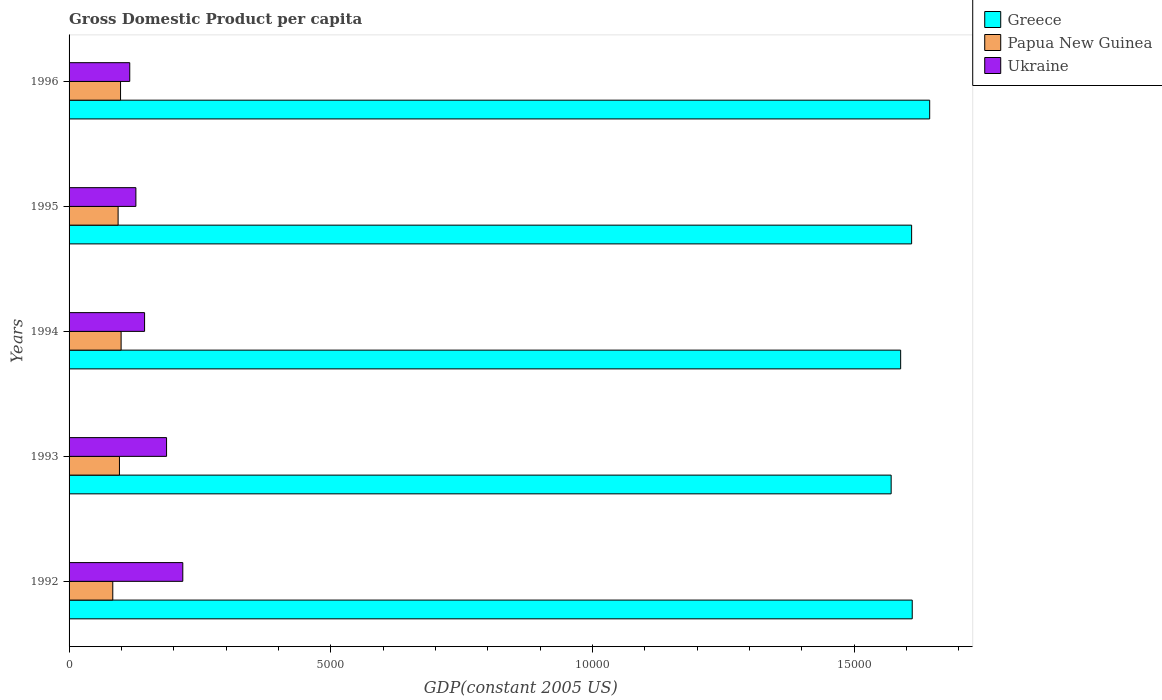How many different coloured bars are there?
Provide a short and direct response. 3. How many groups of bars are there?
Provide a short and direct response. 5. Are the number of bars per tick equal to the number of legend labels?
Your answer should be compact. Yes. What is the label of the 3rd group of bars from the top?
Offer a very short reply. 1994. In how many cases, is the number of bars for a given year not equal to the number of legend labels?
Make the answer very short. 0. What is the GDP per capita in Ukraine in 1996?
Your answer should be very brief. 1159.47. Across all years, what is the maximum GDP per capita in Papua New Guinea?
Make the answer very short. 994.42. Across all years, what is the minimum GDP per capita in Greece?
Provide a short and direct response. 1.57e+04. In which year was the GDP per capita in Ukraine maximum?
Keep it short and to the point. 1992. What is the total GDP per capita in Papua New Guinea in the graph?
Your response must be concise. 4713.17. What is the difference between the GDP per capita in Greece in 1993 and that in 1996?
Provide a short and direct response. -736.03. What is the difference between the GDP per capita in Papua New Guinea in 1996 and the GDP per capita in Greece in 1995?
Offer a very short reply. -1.51e+04. What is the average GDP per capita in Ukraine per year?
Offer a very short reply. 1583.11. In the year 1993, what is the difference between the GDP per capita in Ukraine and GDP per capita in Papua New Guinea?
Ensure brevity in your answer.  900.2. In how many years, is the GDP per capita in Papua New Guinea greater than 3000 US$?
Offer a very short reply. 0. What is the ratio of the GDP per capita in Greece in 1993 to that in 1996?
Your response must be concise. 0.96. Is the GDP per capita in Papua New Guinea in 1994 less than that in 1995?
Your response must be concise. No. Is the difference between the GDP per capita in Ukraine in 1994 and 1996 greater than the difference between the GDP per capita in Papua New Guinea in 1994 and 1996?
Your answer should be very brief. Yes. What is the difference between the highest and the second highest GDP per capita in Greece?
Your answer should be compact. 333.31. What is the difference between the highest and the lowest GDP per capita in Ukraine?
Offer a terse response. 1013.76. Is the sum of the GDP per capita in Greece in 1992 and 1993 greater than the maximum GDP per capita in Papua New Guinea across all years?
Offer a terse response. Yes. What does the 2nd bar from the top in 1996 represents?
Make the answer very short. Papua New Guinea. Are all the bars in the graph horizontal?
Keep it short and to the point. Yes. How many years are there in the graph?
Make the answer very short. 5. Are the values on the major ticks of X-axis written in scientific E-notation?
Make the answer very short. No. Does the graph contain grids?
Your answer should be very brief. No. Where does the legend appear in the graph?
Your response must be concise. Top right. How are the legend labels stacked?
Provide a succinct answer. Vertical. What is the title of the graph?
Ensure brevity in your answer.  Gross Domestic Product per capita. Does "Indonesia" appear as one of the legend labels in the graph?
Your answer should be very brief. No. What is the label or title of the X-axis?
Your response must be concise. GDP(constant 2005 US). What is the label or title of the Y-axis?
Provide a succinct answer. Years. What is the GDP(constant 2005 US) in Greece in 1992?
Give a very brief answer. 1.61e+04. What is the GDP(constant 2005 US) in Papua New Guinea in 1992?
Provide a short and direct response. 835.3. What is the GDP(constant 2005 US) of Ukraine in 1992?
Keep it short and to the point. 2173.23. What is the GDP(constant 2005 US) in Greece in 1993?
Give a very brief answer. 1.57e+04. What is the GDP(constant 2005 US) of Papua New Guinea in 1993?
Give a very brief answer. 962.82. What is the GDP(constant 2005 US) in Ukraine in 1993?
Offer a terse response. 1863.03. What is the GDP(constant 2005 US) in Greece in 1994?
Offer a very short reply. 1.59e+04. What is the GDP(constant 2005 US) in Papua New Guinea in 1994?
Provide a short and direct response. 994.42. What is the GDP(constant 2005 US) of Ukraine in 1994?
Give a very brief answer. 1442.9. What is the GDP(constant 2005 US) in Greece in 1995?
Provide a short and direct response. 1.61e+04. What is the GDP(constant 2005 US) in Papua New Guinea in 1995?
Your response must be concise. 937.05. What is the GDP(constant 2005 US) in Ukraine in 1995?
Offer a very short reply. 1276.92. What is the GDP(constant 2005 US) in Greece in 1996?
Give a very brief answer. 1.64e+04. What is the GDP(constant 2005 US) of Papua New Guinea in 1996?
Provide a succinct answer. 983.58. What is the GDP(constant 2005 US) of Ukraine in 1996?
Offer a very short reply. 1159.47. Across all years, what is the maximum GDP(constant 2005 US) of Greece?
Your answer should be compact. 1.64e+04. Across all years, what is the maximum GDP(constant 2005 US) in Papua New Guinea?
Give a very brief answer. 994.42. Across all years, what is the maximum GDP(constant 2005 US) in Ukraine?
Make the answer very short. 2173.23. Across all years, what is the minimum GDP(constant 2005 US) of Greece?
Your answer should be compact. 1.57e+04. Across all years, what is the minimum GDP(constant 2005 US) of Papua New Guinea?
Make the answer very short. 835.3. Across all years, what is the minimum GDP(constant 2005 US) in Ukraine?
Provide a short and direct response. 1159.47. What is the total GDP(constant 2005 US) in Greece in the graph?
Make the answer very short. 8.03e+04. What is the total GDP(constant 2005 US) in Papua New Guinea in the graph?
Ensure brevity in your answer.  4713.17. What is the total GDP(constant 2005 US) of Ukraine in the graph?
Ensure brevity in your answer.  7915.54. What is the difference between the GDP(constant 2005 US) in Greece in 1992 and that in 1993?
Your answer should be compact. 402.72. What is the difference between the GDP(constant 2005 US) of Papua New Guinea in 1992 and that in 1993?
Offer a terse response. -127.52. What is the difference between the GDP(constant 2005 US) of Ukraine in 1992 and that in 1993?
Provide a succinct answer. 310.2. What is the difference between the GDP(constant 2005 US) of Greece in 1992 and that in 1994?
Offer a terse response. 221.4. What is the difference between the GDP(constant 2005 US) in Papua New Guinea in 1992 and that in 1994?
Your response must be concise. -159.11. What is the difference between the GDP(constant 2005 US) of Ukraine in 1992 and that in 1994?
Offer a terse response. 730.33. What is the difference between the GDP(constant 2005 US) in Greece in 1992 and that in 1995?
Offer a terse response. 11.85. What is the difference between the GDP(constant 2005 US) of Papua New Guinea in 1992 and that in 1995?
Give a very brief answer. -101.75. What is the difference between the GDP(constant 2005 US) of Ukraine in 1992 and that in 1995?
Your answer should be compact. 896.31. What is the difference between the GDP(constant 2005 US) of Greece in 1992 and that in 1996?
Make the answer very short. -333.31. What is the difference between the GDP(constant 2005 US) in Papua New Guinea in 1992 and that in 1996?
Provide a succinct answer. -148.28. What is the difference between the GDP(constant 2005 US) of Ukraine in 1992 and that in 1996?
Your response must be concise. 1013.76. What is the difference between the GDP(constant 2005 US) in Greece in 1993 and that in 1994?
Your response must be concise. -181.32. What is the difference between the GDP(constant 2005 US) in Papua New Guinea in 1993 and that in 1994?
Make the answer very short. -31.59. What is the difference between the GDP(constant 2005 US) in Ukraine in 1993 and that in 1994?
Provide a short and direct response. 420.13. What is the difference between the GDP(constant 2005 US) of Greece in 1993 and that in 1995?
Offer a terse response. -390.87. What is the difference between the GDP(constant 2005 US) of Papua New Guinea in 1993 and that in 1995?
Keep it short and to the point. 25.77. What is the difference between the GDP(constant 2005 US) of Ukraine in 1993 and that in 1995?
Your answer should be very brief. 586.11. What is the difference between the GDP(constant 2005 US) of Greece in 1993 and that in 1996?
Provide a succinct answer. -736.03. What is the difference between the GDP(constant 2005 US) of Papua New Guinea in 1993 and that in 1996?
Offer a terse response. -20.75. What is the difference between the GDP(constant 2005 US) of Ukraine in 1993 and that in 1996?
Ensure brevity in your answer.  703.56. What is the difference between the GDP(constant 2005 US) of Greece in 1994 and that in 1995?
Provide a short and direct response. -209.55. What is the difference between the GDP(constant 2005 US) of Papua New Guinea in 1994 and that in 1995?
Give a very brief answer. 57.36. What is the difference between the GDP(constant 2005 US) in Ukraine in 1994 and that in 1995?
Offer a terse response. 165.98. What is the difference between the GDP(constant 2005 US) in Greece in 1994 and that in 1996?
Ensure brevity in your answer.  -554.71. What is the difference between the GDP(constant 2005 US) of Papua New Guinea in 1994 and that in 1996?
Ensure brevity in your answer.  10.84. What is the difference between the GDP(constant 2005 US) of Ukraine in 1994 and that in 1996?
Your response must be concise. 283.43. What is the difference between the GDP(constant 2005 US) in Greece in 1995 and that in 1996?
Your response must be concise. -345.16. What is the difference between the GDP(constant 2005 US) in Papua New Guinea in 1995 and that in 1996?
Your answer should be compact. -46.53. What is the difference between the GDP(constant 2005 US) in Ukraine in 1995 and that in 1996?
Offer a terse response. 117.45. What is the difference between the GDP(constant 2005 US) of Greece in 1992 and the GDP(constant 2005 US) of Papua New Guinea in 1993?
Make the answer very short. 1.51e+04. What is the difference between the GDP(constant 2005 US) in Greece in 1992 and the GDP(constant 2005 US) in Ukraine in 1993?
Your answer should be compact. 1.42e+04. What is the difference between the GDP(constant 2005 US) in Papua New Guinea in 1992 and the GDP(constant 2005 US) in Ukraine in 1993?
Make the answer very short. -1027.72. What is the difference between the GDP(constant 2005 US) in Greece in 1992 and the GDP(constant 2005 US) in Papua New Guinea in 1994?
Give a very brief answer. 1.51e+04. What is the difference between the GDP(constant 2005 US) in Greece in 1992 and the GDP(constant 2005 US) in Ukraine in 1994?
Your answer should be compact. 1.47e+04. What is the difference between the GDP(constant 2005 US) in Papua New Guinea in 1992 and the GDP(constant 2005 US) in Ukraine in 1994?
Keep it short and to the point. -607.6. What is the difference between the GDP(constant 2005 US) in Greece in 1992 and the GDP(constant 2005 US) in Papua New Guinea in 1995?
Offer a very short reply. 1.52e+04. What is the difference between the GDP(constant 2005 US) in Greece in 1992 and the GDP(constant 2005 US) in Ukraine in 1995?
Make the answer very short. 1.48e+04. What is the difference between the GDP(constant 2005 US) in Papua New Guinea in 1992 and the GDP(constant 2005 US) in Ukraine in 1995?
Your answer should be very brief. -441.62. What is the difference between the GDP(constant 2005 US) of Greece in 1992 and the GDP(constant 2005 US) of Papua New Guinea in 1996?
Offer a terse response. 1.51e+04. What is the difference between the GDP(constant 2005 US) of Greece in 1992 and the GDP(constant 2005 US) of Ukraine in 1996?
Offer a very short reply. 1.50e+04. What is the difference between the GDP(constant 2005 US) in Papua New Guinea in 1992 and the GDP(constant 2005 US) in Ukraine in 1996?
Your response must be concise. -324.17. What is the difference between the GDP(constant 2005 US) in Greece in 1993 and the GDP(constant 2005 US) in Papua New Guinea in 1994?
Offer a terse response. 1.47e+04. What is the difference between the GDP(constant 2005 US) of Greece in 1993 and the GDP(constant 2005 US) of Ukraine in 1994?
Your answer should be very brief. 1.43e+04. What is the difference between the GDP(constant 2005 US) in Papua New Guinea in 1993 and the GDP(constant 2005 US) in Ukraine in 1994?
Provide a succinct answer. -480.07. What is the difference between the GDP(constant 2005 US) of Greece in 1993 and the GDP(constant 2005 US) of Papua New Guinea in 1995?
Ensure brevity in your answer.  1.48e+04. What is the difference between the GDP(constant 2005 US) of Greece in 1993 and the GDP(constant 2005 US) of Ukraine in 1995?
Your answer should be very brief. 1.44e+04. What is the difference between the GDP(constant 2005 US) in Papua New Guinea in 1993 and the GDP(constant 2005 US) in Ukraine in 1995?
Offer a very short reply. -314.09. What is the difference between the GDP(constant 2005 US) in Greece in 1993 and the GDP(constant 2005 US) in Papua New Guinea in 1996?
Your response must be concise. 1.47e+04. What is the difference between the GDP(constant 2005 US) of Greece in 1993 and the GDP(constant 2005 US) of Ukraine in 1996?
Make the answer very short. 1.46e+04. What is the difference between the GDP(constant 2005 US) in Papua New Guinea in 1993 and the GDP(constant 2005 US) in Ukraine in 1996?
Keep it short and to the point. -196.65. What is the difference between the GDP(constant 2005 US) of Greece in 1994 and the GDP(constant 2005 US) of Papua New Guinea in 1995?
Provide a succinct answer. 1.50e+04. What is the difference between the GDP(constant 2005 US) of Greece in 1994 and the GDP(constant 2005 US) of Ukraine in 1995?
Ensure brevity in your answer.  1.46e+04. What is the difference between the GDP(constant 2005 US) in Papua New Guinea in 1994 and the GDP(constant 2005 US) in Ukraine in 1995?
Offer a very short reply. -282.5. What is the difference between the GDP(constant 2005 US) of Greece in 1994 and the GDP(constant 2005 US) of Papua New Guinea in 1996?
Your answer should be compact. 1.49e+04. What is the difference between the GDP(constant 2005 US) in Greece in 1994 and the GDP(constant 2005 US) in Ukraine in 1996?
Keep it short and to the point. 1.47e+04. What is the difference between the GDP(constant 2005 US) in Papua New Guinea in 1994 and the GDP(constant 2005 US) in Ukraine in 1996?
Provide a succinct answer. -165.05. What is the difference between the GDP(constant 2005 US) in Greece in 1995 and the GDP(constant 2005 US) in Papua New Guinea in 1996?
Offer a very short reply. 1.51e+04. What is the difference between the GDP(constant 2005 US) in Greece in 1995 and the GDP(constant 2005 US) in Ukraine in 1996?
Offer a very short reply. 1.49e+04. What is the difference between the GDP(constant 2005 US) of Papua New Guinea in 1995 and the GDP(constant 2005 US) of Ukraine in 1996?
Your answer should be very brief. -222.42. What is the average GDP(constant 2005 US) of Greece per year?
Your response must be concise. 1.61e+04. What is the average GDP(constant 2005 US) in Papua New Guinea per year?
Offer a very short reply. 942.63. What is the average GDP(constant 2005 US) of Ukraine per year?
Your response must be concise. 1583.11. In the year 1992, what is the difference between the GDP(constant 2005 US) in Greece and GDP(constant 2005 US) in Papua New Guinea?
Offer a very short reply. 1.53e+04. In the year 1992, what is the difference between the GDP(constant 2005 US) of Greece and GDP(constant 2005 US) of Ukraine?
Offer a very short reply. 1.39e+04. In the year 1992, what is the difference between the GDP(constant 2005 US) of Papua New Guinea and GDP(constant 2005 US) of Ukraine?
Make the answer very short. -1337.92. In the year 1993, what is the difference between the GDP(constant 2005 US) in Greece and GDP(constant 2005 US) in Papua New Guinea?
Offer a terse response. 1.47e+04. In the year 1993, what is the difference between the GDP(constant 2005 US) of Greece and GDP(constant 2005 US) of Ukraine?
Ensure brevity in your answer.  1.38e+04. In the year 1993, what is the difference between the GDP(constant 2005 US) in Papua New Guinea and GDP(constant 2005 US) in Ukraine?
Give a very brief answer. -900.2. In the year 1994, what is the difference between the GDP(constant 2005 US) in Greece and GDP(constant 2005 US) in Papua New Guinea?
Make the answer very short. 1.49e+04. In the year 1994, what is the difference between the GDP(constant 2005 US) in Greece and GDP(constant 2005 US) in Ukraine?
Give a very brief answer. 1.44e+04. In the year 1994, what is the difference between the GDP(constant 2005 US) in Papua New Guinea and GDP(constant 2005 US) in Ukraine?
Give a very brief answer. -448.48. In the year 1995, what is the difference between the GDP(constant 2005 US) in Greece and GDP(constant 2005 US) in Papua New Guinea?
Your answer should be compact. 1.52e+04. In the year 1995, what is the difference between the GDP(constant 2005 US) of Greece and GDP(constant 2005 US) of Ukraine?
Provide a short and direct response. 1.48e+04. In the year 1995, what is the difference between the GDP(constant 2005 US) in Papua New Guinea and GDP(constant 2005 US) in Ukraine?
Your answer should be compact. -339.87. In the year 1996, what is the difference between the GDP(constant 2005 US) of Greece and GDP(constant 2005 US) of Papua New Guinea?
Your response must be concise. 1.55e+04. In the year 1996, what is the difference between the GDP(constant 2005 US) of Greece and GDP(constant 2005 US) of Ukraine?
Provide a succinct answer. 1.53e+04. In the year 1996, what is the difference between the GDP(constant 2005 US) of Papua New Guinea and GDP(constant 2005 US) of Ukraine?
Offer a terse response. -175.89. What is the ratio of the GDP(constant 2005 US) in Greece in 1992 to that in 1993?
Make the answer very short. 1.03. What is the ratio of the GDP(constant 2005 US) of Papua New Guinea in 1992 to that in 1993?
Provide a short and direct response. 0.87. What is the ratio of the GDP(constant 2005 US) of Ukraine in 1992 to that in 1993?
Offer a terse response. 1.17. What is the ratio of the GDP(constant 2005 US) in Greece in 1992 to that in 1994?
Give a very brief answer. 1.01. What is the ratio of the GDP(constant 2005 US) of Papua New Guinea in 1992 to that in 1994?
Offer a terse response. 0.84. What is the ratio of the GDP(constant 2005 US) of Ukraine in 1992 to that in 1994?
Your response must be concise. 1.51. What is the ratio of the GDP(constant 2005 US) in Papua New Guinea in 1992 to that in 1995?
Keep it short and to the point. 0.89. What is the ratio of the GDP(constant 2005 US) in Ukraine in 1992 to that in 1995?
Your answer should be compact. 1.7. What is the ratio of the GDP(constant 2005 US) in Greece in 1992 to that in 1996?
Keep it short and to the point. 0.98. What is the ratio of the GDP(constant 2005 US) in Papua New Guinea in 1992 to that in 1996?
Your answer should be very brief. 0.85. What is the ratio of the GDP(constant 2005 US) in Ukraine in 1992 to that in 1996?
Provide a succinct answer. 1.87. What is the ratio of the GDP(constant 2005 US) in Papua New Guinea in 1993 to that in 1994?
Give a very brief answer. 0.97. What is the ratio of the GDP(constant 2005 US) in Ukraine in 1993 to that in 1994?
Keep it short and to the point. 1.29. What is the ratio of the GDP(constant 2005 US) of Greece in 1993 to that in 1995?
Offer a very short reply. 0.98. What is the ratio of the GDP(constant 2005 US) in Papua New Guinea in 1993 to that in 1995?
Offer a terse response. 1.03. What is the ratio of the GDP(constant 2005 US) of Ukraine in 1993 to that in 1995?
Give a very brief answer. 1.46. What is the ratio of the GDP(constant 2005 US) of Greece in 1993 to that in 1996?
Offer a very short reply. 0.96. What is the ratio of the GDP(constant 2005 US) of Papua New Guinea in 1993 to that in 1996?
Give a very brief answer. 0.98. What is the ratio of the GDP(constant 2005 US) in Ukraine in 1993 to that in 1996?
Ensure brevity in your answer.  1.61. What is the ratio of the GDP(constant 2005 US) in Papua New Guinea in 1994 to that in 1995?
Provide a short and direct response. 1.06. What is the ratio of the GDP(constant 2005 US) in Ukraine in 1994 to that in 1995?
Your answer should be very brief. 1.13. What is the ratio of the GDP(constant 2005 US) in Greece in 1994 to that in 1996?
Your response must be concise. 0.97. What is the ratio of the GDP(constant 2005 US) of Papua New Guinea in 1994 to that in 1996?
Your answer should be very brief. 1.01. What is the ratio of the GDP(constant 2005 US) in Ukraine in 1994 to that in 1996?
Provide a succinct answer. 1.24. What is the ratio of the GDP(constant 2005 US) of Greece in 1995 to that in 1996?
Your response must be concise. 0.98. What is the ratio of the GDP(constant 2005 US) in Papua New Guinea in 1995 to that in 1996?
Provide a succinct answer. 0.95. What is the ratio of the GDP(constant 2005 US) in Ukraine in 1995 to that in 1996?
Make the answer very short. 1.1. What is the difference between the highest and the second highest GDP(constant 2005 US) of Greece?
Your response must be concise. 333.31. What is the difference between the highest and the second highest GDP(constant 2005 US) in Papua New Guinea?
Provide a short and direct response. 10.84. What is the difference between the highest and the second highest GDP(constant 2005 US) of Ukraine?
Give a very brief answer. 310.2. What is the difference between the highest and the lowest GDP(constant 2005 US) in Greece?
Provide a succinct answer. 736.03. What is the difference between the highest and the lowest GDP(constant 2005 US) in Papua New Guinea?
Your answer should be compact. 159.11. What is the difference between the highest and the lowest GDP(constant 2005 US) of Ukraine?
Offer a terse response. 1013.76. 